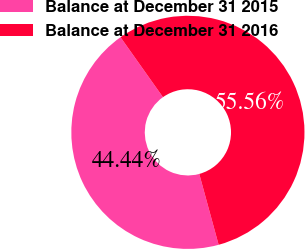Convert chart to OTSL. <chart><loc_0><loc_0><loc_500><loc_500><pie_chart><fcel>Balance at December 31 2015<fcel>Balance at December 31 2016<nl><fcel>44.44%<fcel>55.56%<nl></chart> 